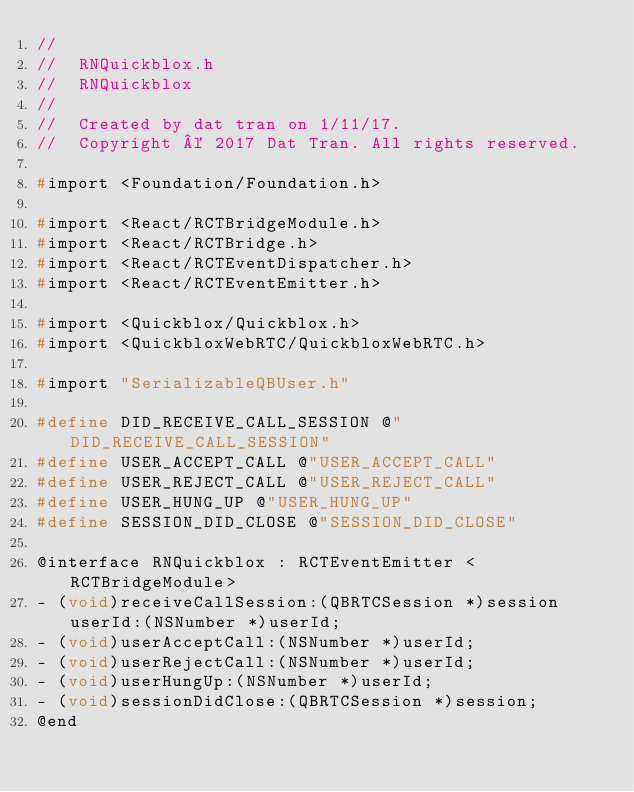Convert code to text. <code><loc_0><loc_0><loc_500><loc_500><_C_>//
//  RNQuickblox.h
//  RNQuickblox
//
//  Created by dat tran on 1/11/17.
//  Copyright © 2017 Dat Tran. All rights reserved.

#import <Foundation/Foundation.h>

#import <React/RCTBridgeModule.h>
#import <React/RCTBridge.h>
#import <React/RCTEventDispatcher.h>
#import <React/RCTEventEmitter.h>

#import <Quickblox/Quickblox.h>
#import <QuickbloxWebRTC/QuickbloxWebRTC.h>

#import "SerializableQBUser.h"

#define DID_RECEIVE_CALL_SESSION @"DID_RECEIVE_CALL_SESSION"
#define USER_ACCEPT_CALL @"USER_ACCEPT_CALL"
#define USER_REJECT_CALL @"USER_REJECT_CALL"
#define USER_HUNG_UP @"USER_HUNG_UP"
#define SESSION_DID_CLOSE @"SESSION_DID_CLOSE"

@interface RNQuickblox : RCTEventEmitter <RCTBridgeModule>
- (void)receiveCallSession:(QBRTCSession *)session userId:(NSNumber *)userId;
- (void)userAcceptCall:(NSNumber *)userId;
- (void)userRejectCall:(NSNumber *)userId;
- (void)userHungUp:(NSNumber *)userId;
- (void)sessionDidClose:(QBRTCSession *)session;
@end
  
</code> 